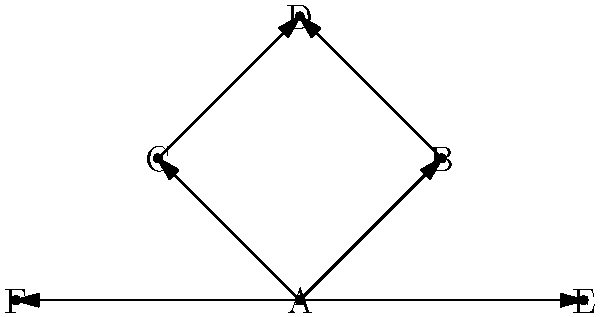In this character interaction network for a postmodern techno-narrative, which character serves as the primary hub, connecting the most other characters directly? How might this structure influence the flow of information or technological elements in the story? To determine the primary hub in this character interaction network, we need to analyze the connections of each character:

1. Character A:
   - Directly connected to B, C, E, and F
   - Total direct connections: 4

2. Character B:
   - Directly connected to A and D
   - Total direct connections: 2

3. Character C:
   - Directly connected to A and D
   - Total direct connections: 2

4. Character D:
   - Directly connected to B and C
   - Total direct connections: 2

5. Character E:
   - Directly connected to A and F
   - Total direct connections: 2

6. Character F:
   - Directly connected to A and E
   - Total direct connections: 2

Character A has the most direct connections (4), making it the primary hub in this network.

This structure influences the flow of information or technological elements in the story by:

1. Centralization: Character A acts as a central point through which information or tech elements can be distributed to other characters.

2. Information control: A has the power to filter or manipulate information before passing it to others.

3. Plot complexity: The hub structure allows for multiple subplots or narrative threads to intersect through A.

4. Character development: A's role as a hub provides opportunities for this character to evolve based on interactions with diverse characters.

5. Narrative pacing: The hub structure enables rapid dissemination of crucial plot points or tech revelations through A to other characters.

This network structure aligns well with a postmodern techno-narrative, allowing for non-linear storytelling and complex character interactions centered around technological themes.
Answer: Character A; centralizes information flow, enabling complex, non-linear narrative structures. 